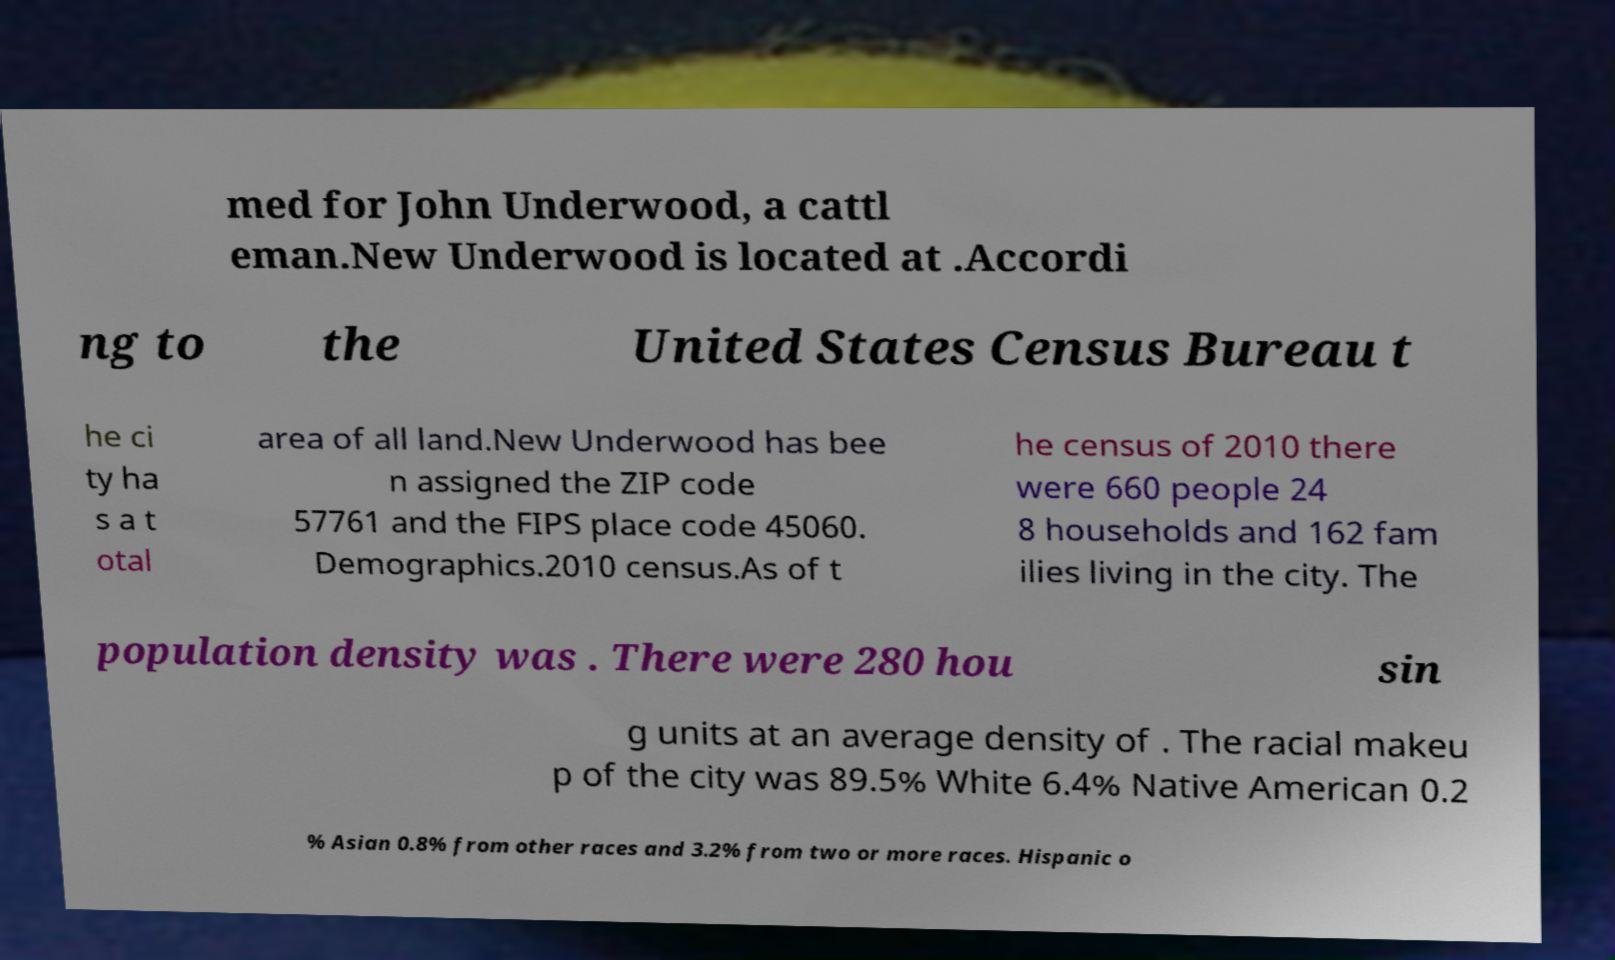I need the written content from this picture converted into text. Can you do that? med for John Underwood, a cattl eman.New Underwood is located at .Accordi ng to the United States Census Bureau t he ci ty ha s a t otal area of all land.New Underwood has bee n assigned the ZIP code 57761 and the FIPS place code 45060. Demographics.2010 census.As of t he census of 2010 there were 660 people 24 8 households and 162 fam ilies living in the city. The population density was . There were 280 hou sin g units at an average density of . The racial makeu p of the city was 89.5% White 6.4% Native American 0.2 % Asian 0.8% from other races and 3.2% from two or more races. Hispanic o 